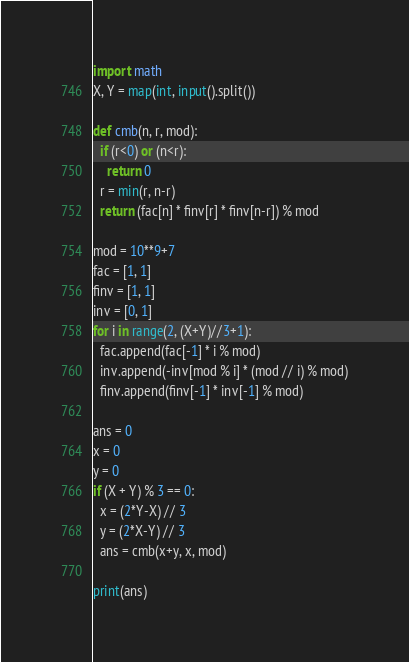Convert code to text. <code><loc_0><loc_0><loc_500><loc_500><_Python_>import math
X, Y = map(int, input().split())
      
def cmb(n, r, mod):
  if (r<0) or (n<r):
    return 0
  r = min(r, n-r)
  return (fac[n] * finv[r] * finv[n-r]) % mod

mod = 10**9+7
fac = [1, 1]
finv = [1, 1]
inv = [0, 1]
for i in range(2, (X+Y)//3+1):
  fac.append(fac[-1] * i % mod)
  inv.append(-inv[mod % i] * (mod // i) % mod)
  finv.append(finv[-1] * inv[-1] % mod)
  
ans = 0
x = 0
y = 0
if (X + Y) % 3 == 0:
  x = (2*Y-X) // 3
  y = (2*X-Y) // 3
  ans = cmb(x+y, x, mod)

print(ans)</code> 